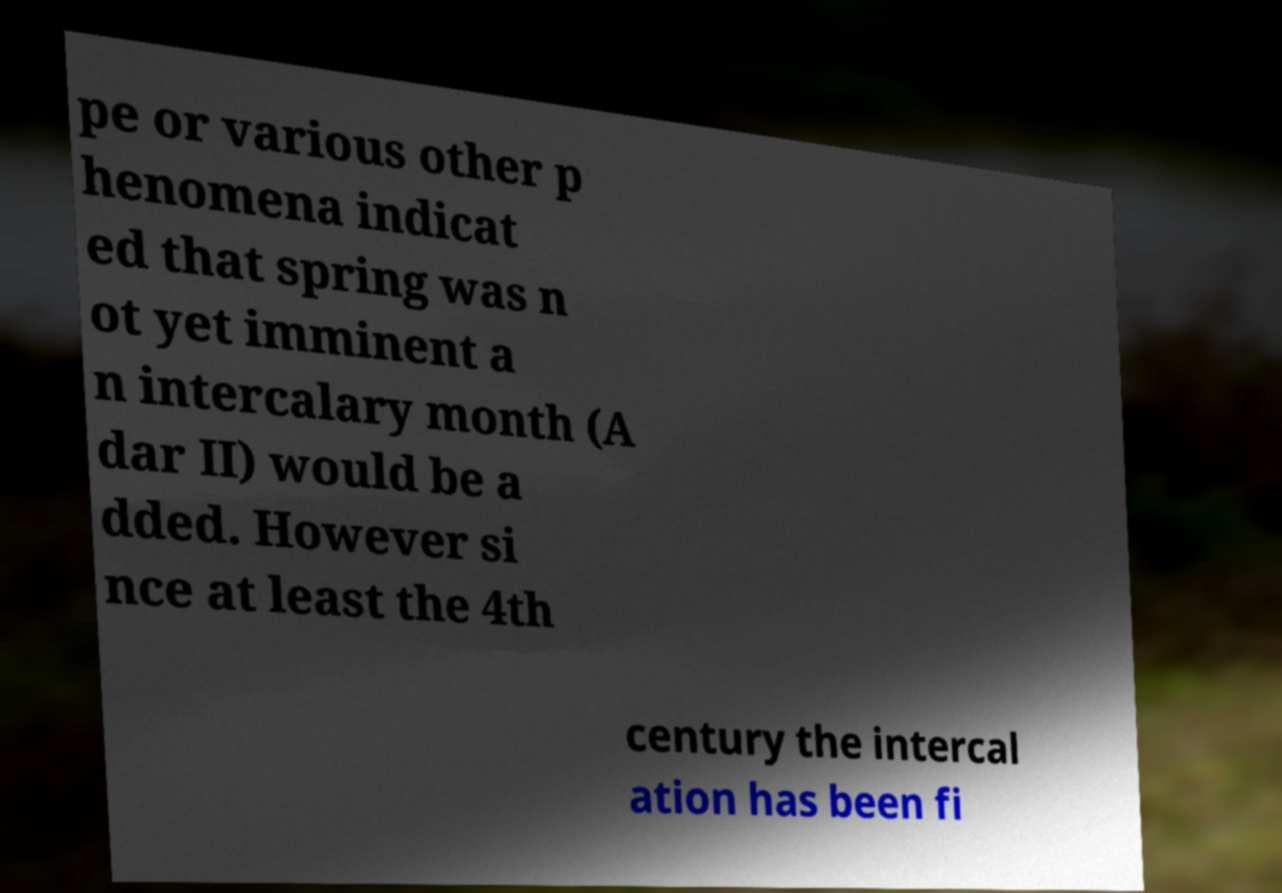I need the written content from this picture converted into text. Can you do that? pe or various other p henomena indicat ed that spring was n ot yet imminent a n intercalary month (A dar II) would be a dded. However si nce at least the 4th century the intercal ation has been fi 